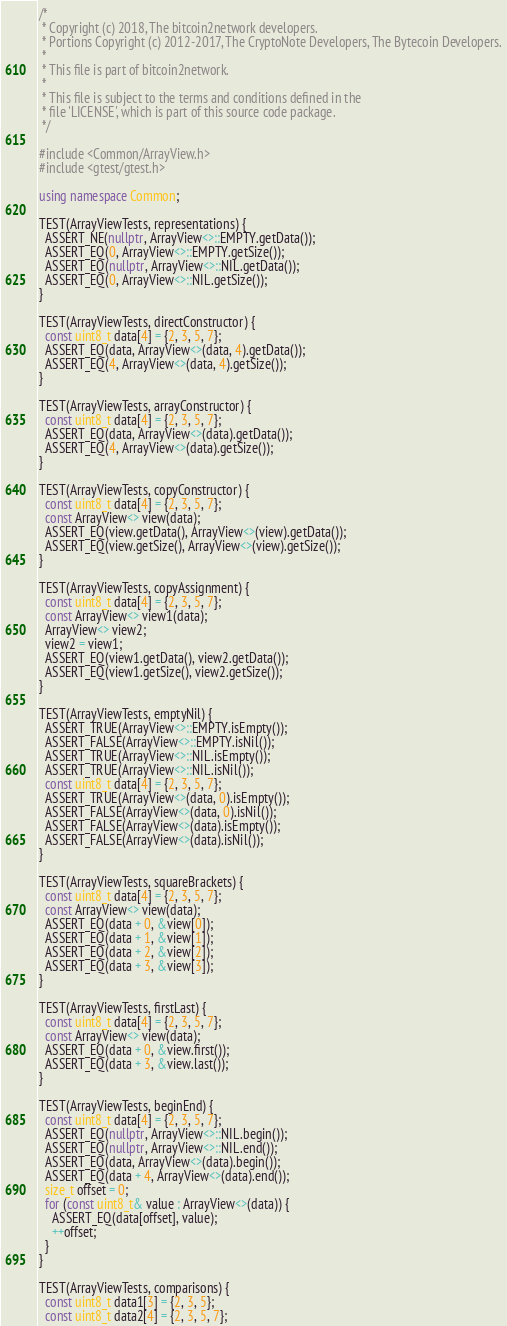<code> <loc_0><loc_0><loc_500><loc_500><_C++_>/*
 * Copyright (c) 2018, The bitcoin2network developers.
 * Portions Copyright (c) 2012-2017, The CryptoNote Developers, The Bytecoin Developers.
 *
 * This file is part of bitcoin2network.
 *
 * This file is subject to the terms and conditions defined in the
 * file 'LICENSE', which is part of this source code package.
 */

#include <Common/ArrayView.h>
#include <gtest/gtest.h>

using namespace Common;

TEST(ArrayViewTests, representations) {
  ASSERT_NE(nullptr, ArrayView<>::EMPTY.getData());
  ASSERT_EQ(0, ArrayView<>::EMPTY.getSize());
  ASSERT_EQ(nullptr, ArrayView<>::NIL.getData());
  ASSERT_EQ(0, ArrayView<>::NIL.getSize());
}

TEST(ArrayViewTests, directConstructor) {
  const uint8_t data[4] = {2, 3, 5, 7};
  ASSERT_EQ(data, ArrayView<>(data, 4).getData());
  ASSERT_EQ(4, ArrayView<>(data, 4).getSize());
}

TEST(ArrayViewTests, arrayConstructor) {
  const uint8_t data[4] = {2, 3, 5, 7};
  ASSERT_EQ(data, ArrayView<>(data).getData());
  ASSERT_EQ(4, ArrayView<>(data).getSize());
}

TEST(ArrayViewTests, copyConstructor) {
  const uint8_t data[4] = {2, 3, 5, 7};
  const ArrayView<> view(data);
  ASSERT_EQ(view.getData(), ArrayView<>(view).getData());
  ASSERT_EQ(view.getSize(), ArrayView<>(view).getSize());
}

TEST(ArrayViewTests, copyAssignment) {
  const uint8_t data[4] = {2, 3, 5, 7};
  const ArrayView<> view1(data);
  ArrayView<> view2;
  view2 = view1;
  ASSERT_EQ(view1.getData(), view2.getData());
  ASSERT_EQ(view1.getSize(), view2.getSize());
}

TEST(ArrayViewTests, emptyNil) {
  ASSERT_TRUE(ArrayView<>::EMPTY.isEmpty());
  ASSERT_FALSE(ArrayView<>::EMPTY.isNil());
  ASSERT_TRUE(ArrayView<>::NIL.isEmpty());
  ASSERT_TRUE(ArrayView<>::NIL.isNil());
  const uint8_t data[4] = {2, 3, 5, 7};
  ASSERT_TRUE(ArrayView<>(data, 0).isEmpty());
  ASSERT_FALSE(ArrayView<>(data, 0).isNil());
  ASSERT_FALSE(ArrayView<>(data).isEmpty());
  ASSERT_FALSE(ArrayView<>(data).isNil());
}

TEST(ArrayViewTests, squareBrackets) {
  const uint8_t data[4] = {2, 3, 5, 7};
  const ArrayView<> view(data);
  ASSERT_EQ(data + 0, &view[0]);
  ASSERT_EQ(data + 1, &view[1]);
  ASSERT_EQ(data + 2, &view[2]);
  ASSERT_EQ(data + 3, &view[3]);
}

TEST(ArrayViewTests, firstLast) {
  const uint8_t data[4] = {2, 3, 5, 7};
  const ArrayView<> view(data);
  ASSERT_EQ(data + 0, &view.first());
  ASSERT_EQ(data + 3, &view.last());
}

TEST(ArrayViewTests, beginEnd) {
  const uint8_t data[4] = {2, 3, 5, 7};
  ASSERT_EQ(nullptr, ArrayView<>::NIL.begin());
  ASSERT_EQ(nullptr, ArrayView<>::NIL.end());
  ASSERT_EQ(data, ArrayView<>(data).begin());
  ASSERT_EQ(data + 4, ArrayView<>(data).end());
  size_t offset = 0;
  for (const uint8_t& value : ArrayView<>(data)) {
    ASSERT_EQ(data[offset], value);
    ++offset;
  }
}

TEST(ArrayViewTests, comparisons) {
  const uint8_t data1[3] = {2, 3, 5};
  const uint8_t data2[4] = {2, 3, 5, 7};</code> 